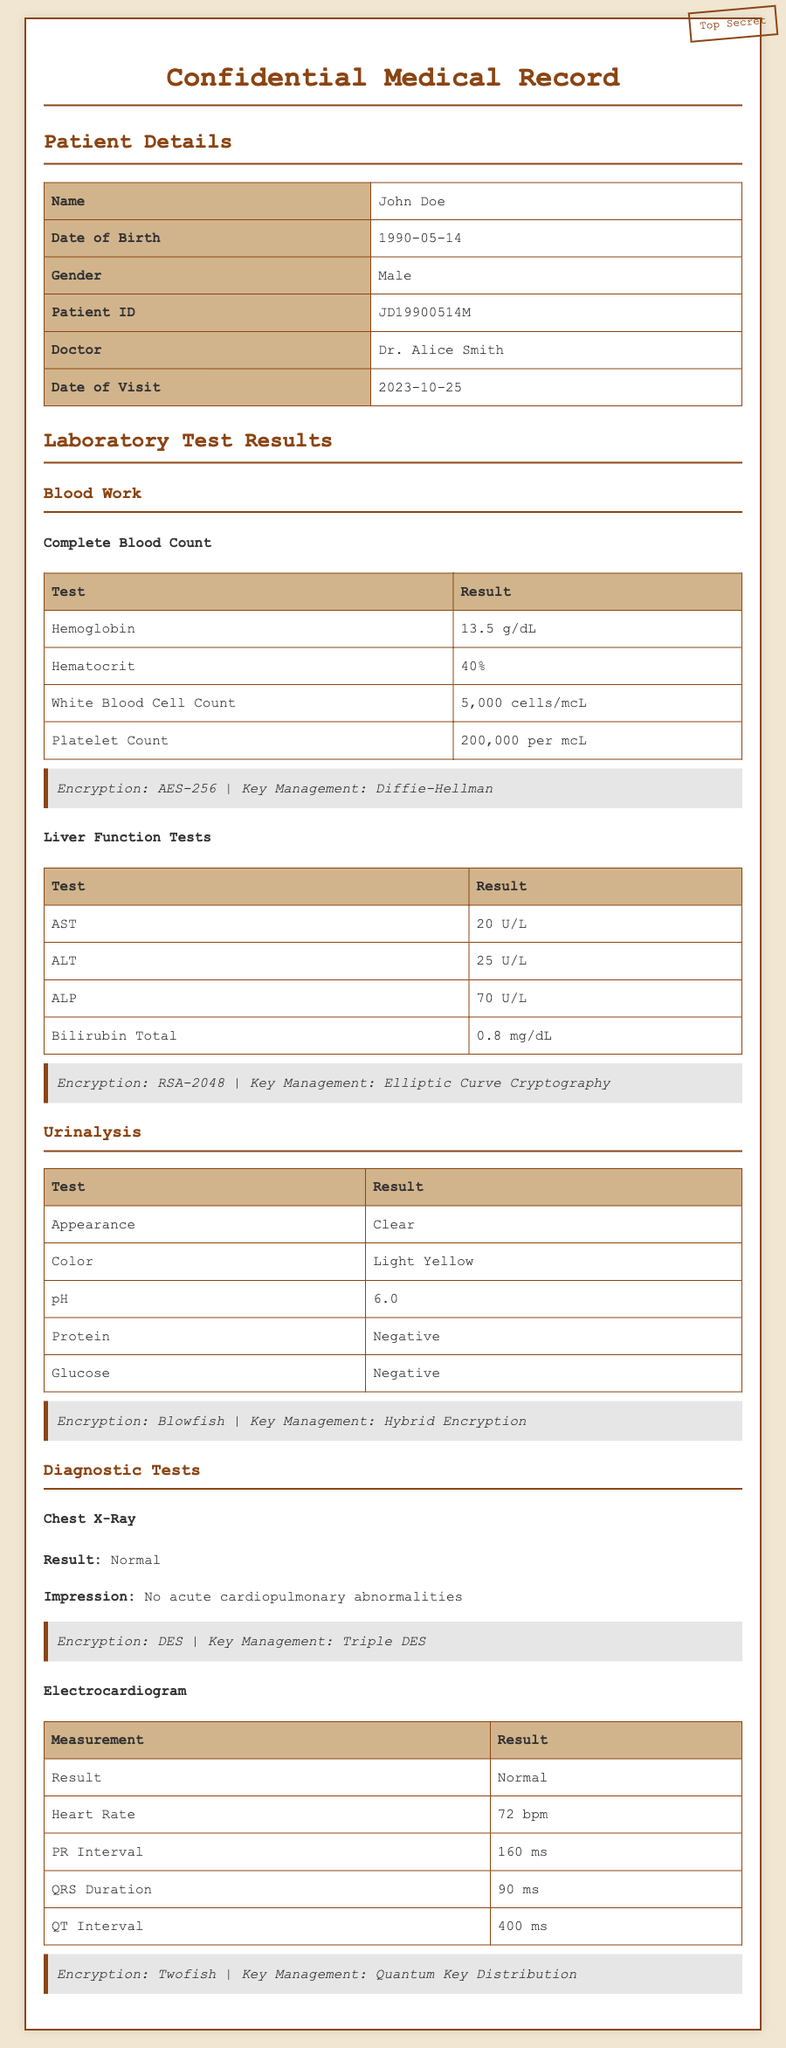what is the patient's name? The patient's name is listed in the Patient Details section of the document.
Answer: John Doe what is the date of visit? The date of visit is clearly stated under Patient Details.
Answer: 2023-10-25 what is the hemoglobin level? The hemoglobin level is found in the Complete Blood Count section of Blood Work.
Answer: 13.5 g/dL what is the result of the AST test? The result of the AST test is provided under Liver Function Tests in the Blood Work section.
Answer: 20 U/L what is the appearance of the urine sample? The urine sample appearance is documented in the Urinalysis section.
Answer: Clear which encryption method is used for the Liver Function Tests? The encryption method for Liver Function Tests is stated under the relevant section in the document.
Answer: RSA-2048 how many measurements are listed in the Electrocardiogram? The number of measurements can be counted by reviewing the Electrocardiogram section.
Answer: 5 what is the management technique mentioned for Blood Work encryption? The key management technique for Blood Work encryption is mentioned in the respective section of the document.
Answer: Diffie-Hellman what impression is noted in the Chest X-Ray results? The impression for the Chest X-Ray is found in the Diagnostic Tests section.
Answer: No acute cardiopulmonary abnormalities 